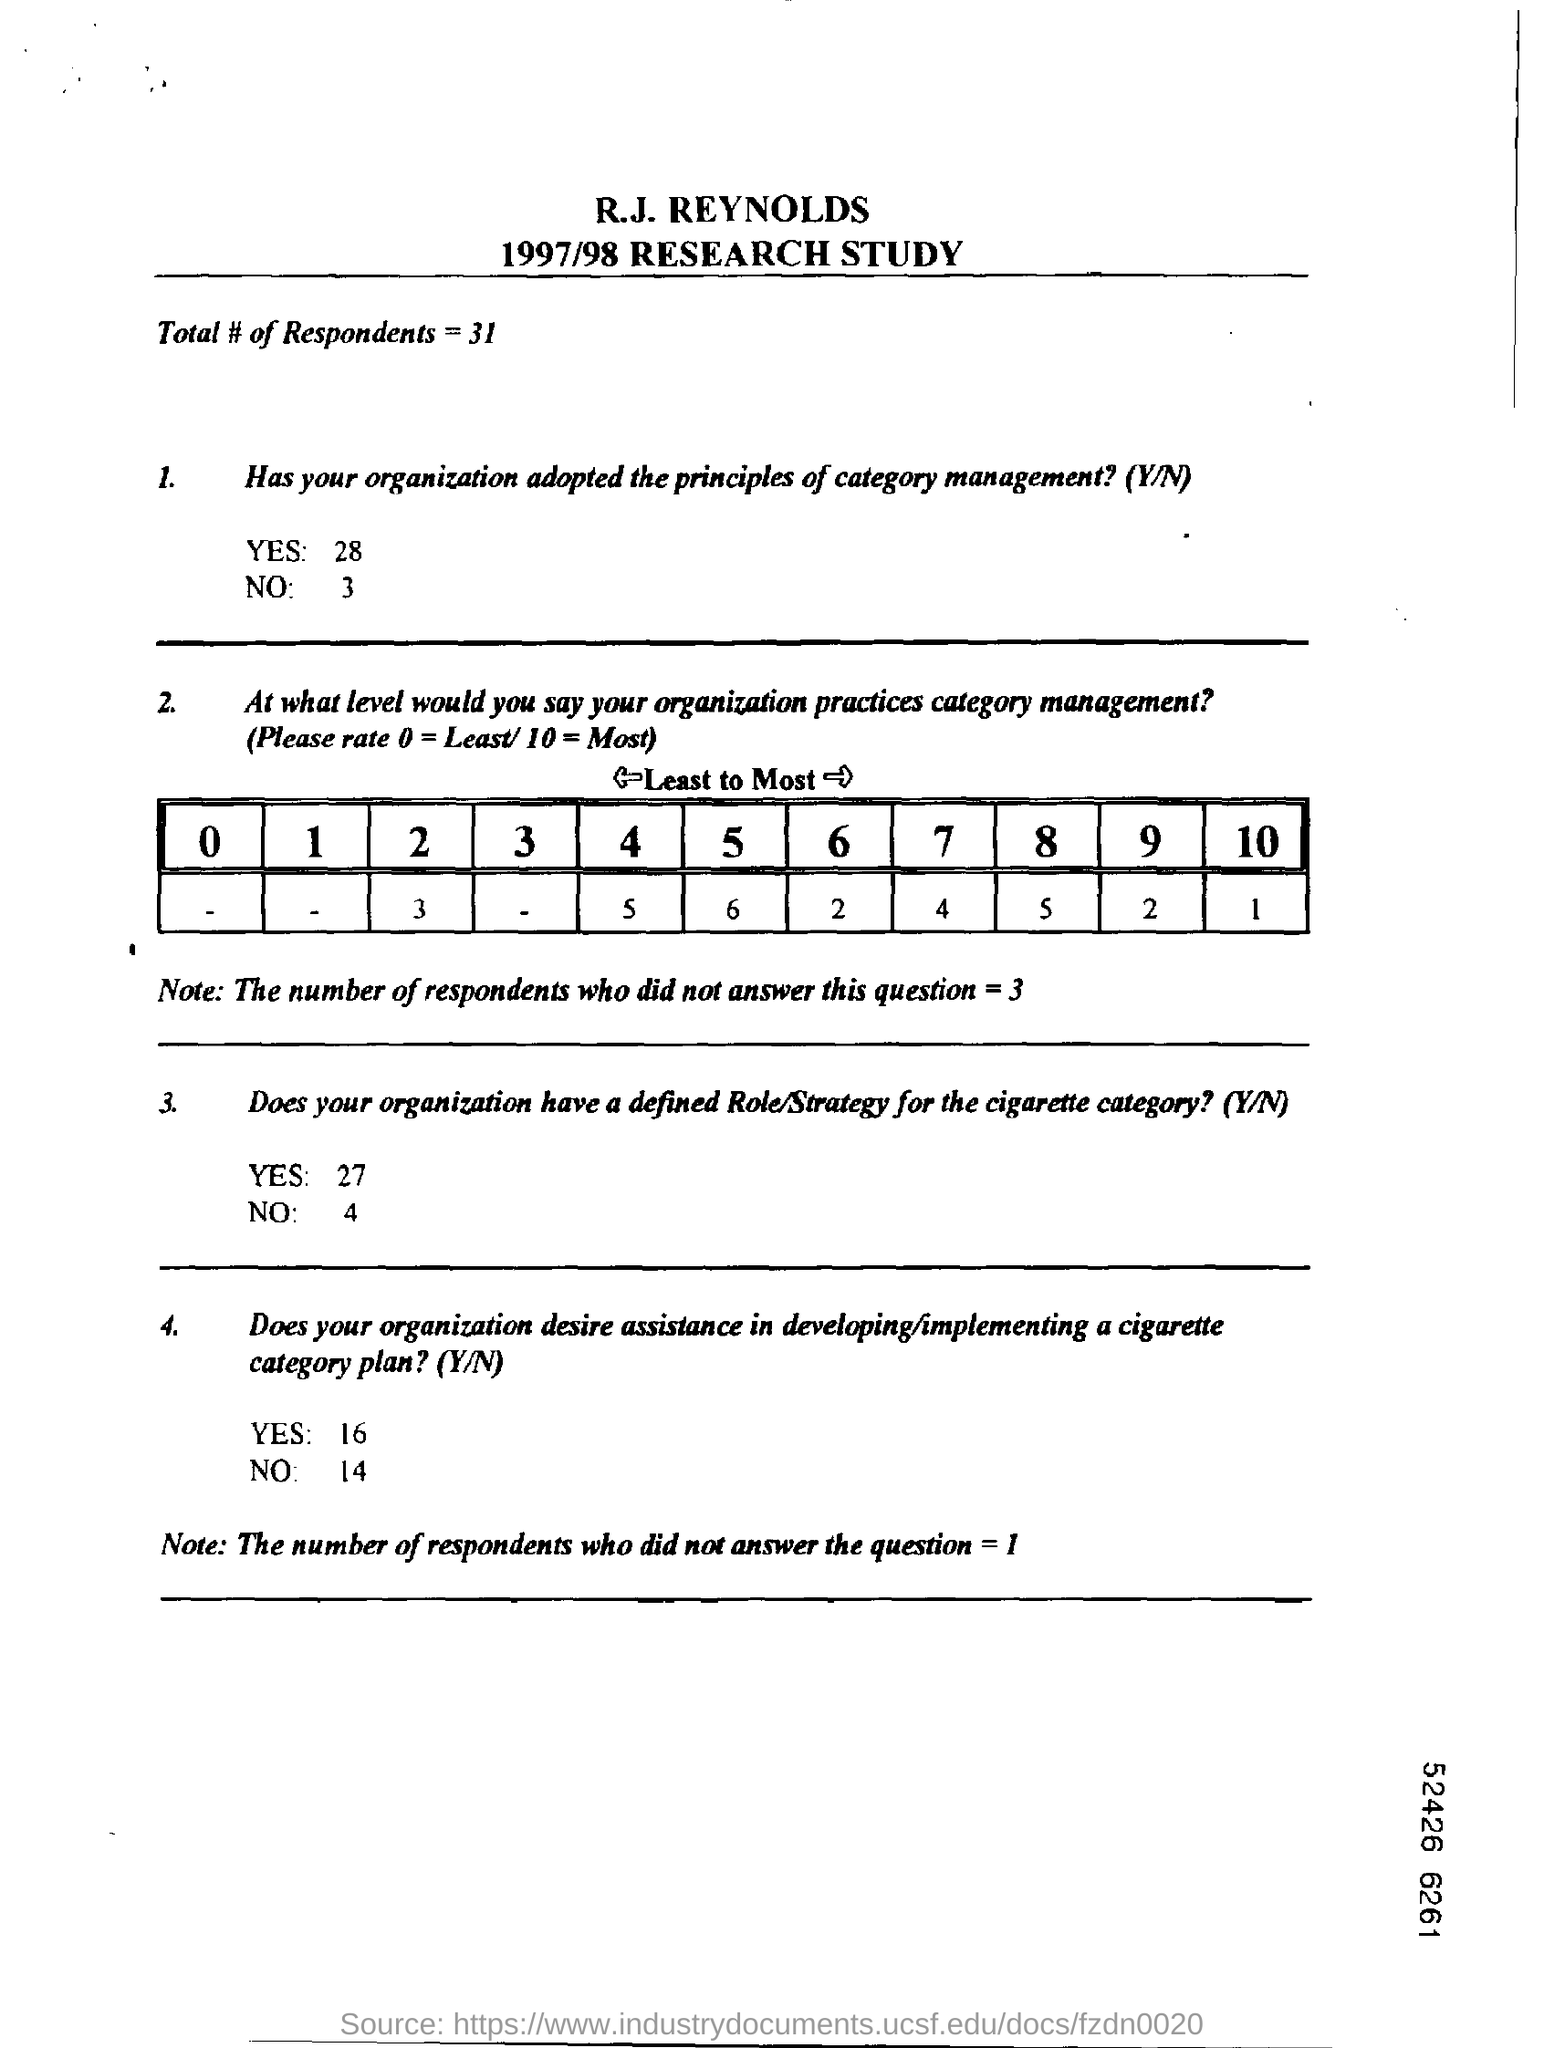List a handful of essential elements in this visual. This document is about a 1997/78 research study. There are a total of 31 respondents. 